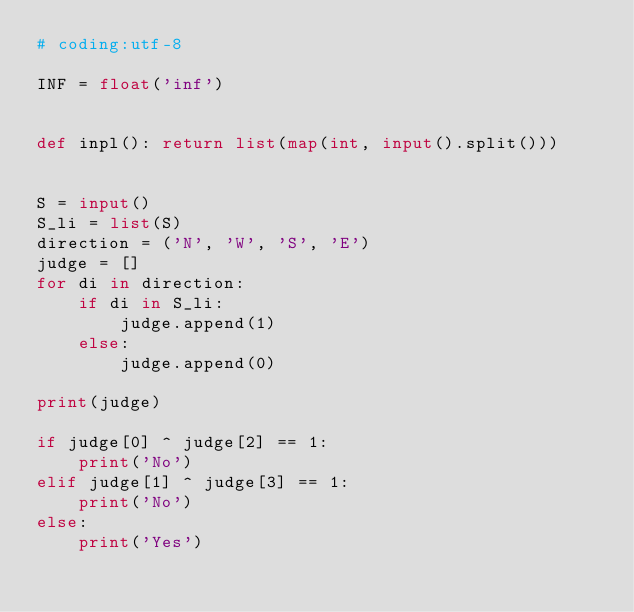<code> <loc_0><loc_0><loc_500><loc_500><_Python_># coding:utf-8

INF = float('inf')


def inpl(): return list(map(int, input().split()))


S = input()
S_li = list(S)
direction = ('N', 'W', 'S', 'E')
judge = []
for di in direction:
    if di in S_li:
        judge.append(1)
    else:
        judge.append(0)

print(judge)

if judge[0] ^ judge[2] == 1:
    print('No')
elif judge[1] ^ judge[3] == 1:
    print('No')
else:
    print('Yes')
</code> 